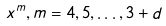Convert formula to latex. <formula><loc_0><loc_0><loc_500><loc_500>x ^ { m } , m = 4 , 5 , \dots , 3 + d</formula> 